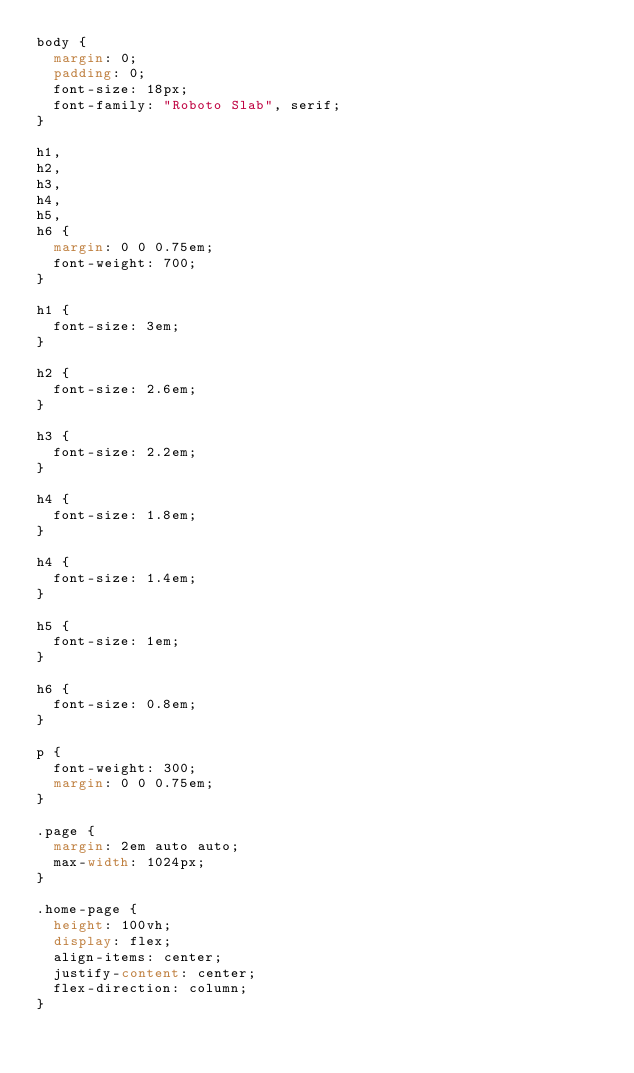<code> <loc_0><loc_0><loc_500><loc_500><_CSS_>body {
  margin: 0;
  padding: 0;
  font-size: 18px;
  font-family: "Roboto Slab", serif;
}

h1,
h2,
h3,
h4,
h5,
h6 {
  margin: 0 0 0.75em;
  font-weight: 700;
}

h1 {
  font-size: 3em;
}

h2 {
  font-size: 2.6em;
}

h3 {
  font-size: 2.2em;
}

h4 {
  font-size: 1.8em;
}

h4 {
  font-size: 1.4em;
}

h5 {
  font-size: 1em;
}

h6 {
  font-size: 0.8em;
}

p {
  font-weight: 300;
  margin: 0 0 0.75em;
}

.page {
  margin: 2em auto auto;
  max-width: 1024px;
}

.home-page {
  height: 100vh;
  display: flex;
  align-items: center;
  justify-content: center;
  flex-direction: column;
}
</code> 